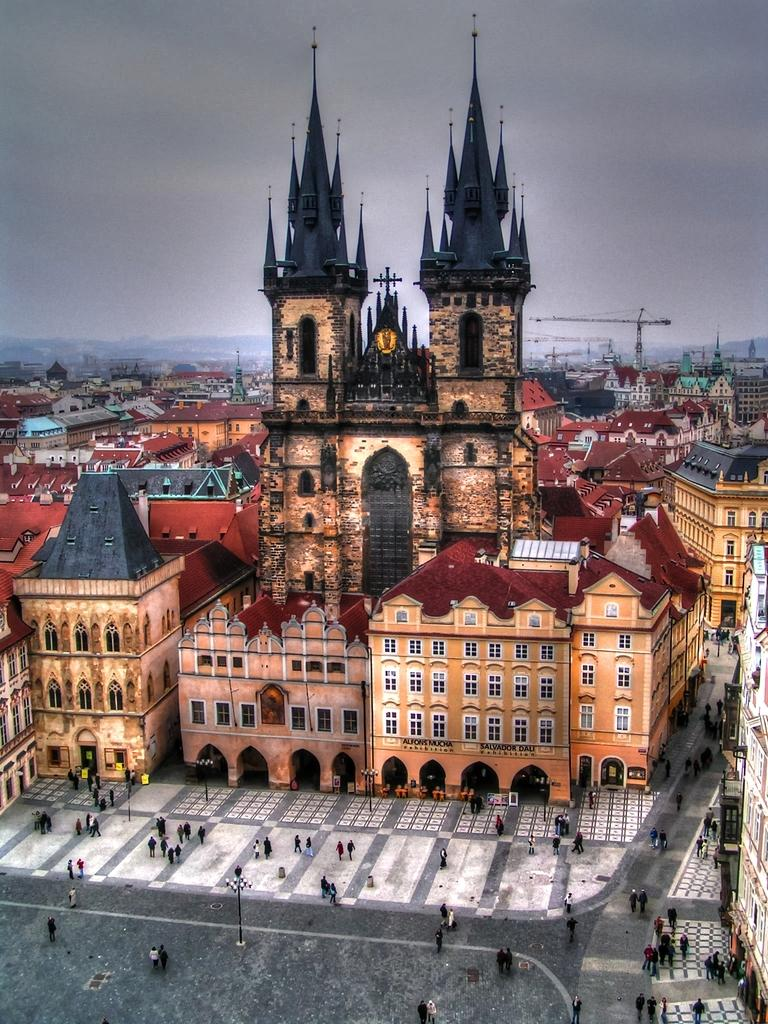What type of structures can be seen in the image? There are buildings in the image. What other objects are present in the image? There are poles and cranes in the image. Are there any living beings visible in the image? Yes, there are people in the image. What can be seen beneath the structures and objects in the image? The ground is visible in the image. What is visible above the structures and objects in the image? The sky is visible in the image, and there are clouds in the sky. What type of egg is being used to paint the buildings in the image? There is no egg present in the image, and the buildings are not being painted. Can you see a wren perched on one of the poles in the image? There is no wren present in the image; only buildings, poles, cranes, people, the ground, and the sky are visible. 